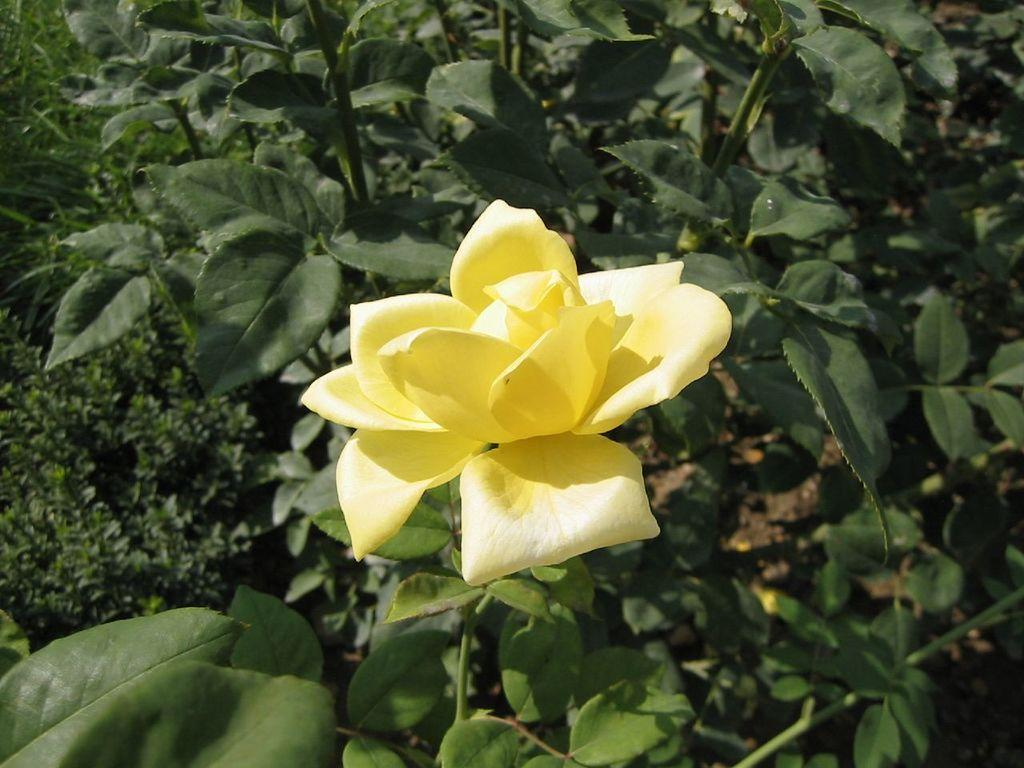What type of flower is on the plant in the image? There is a yellow flower on a plant in the image. How many leaves are visible at the top of the plant in the image? There are many leaves visible at the top of the plant in the image. How many cars are parked next to the yellow flower in the image? There are no cars present in the image; it features a yellow flower on a plant with many leaves. What type of knowledge can be gained from observing the yellow flower in the image? The image does not convey any specific knowledge or information beyond the visual details of the yellow flower and the leaves on the plant. 